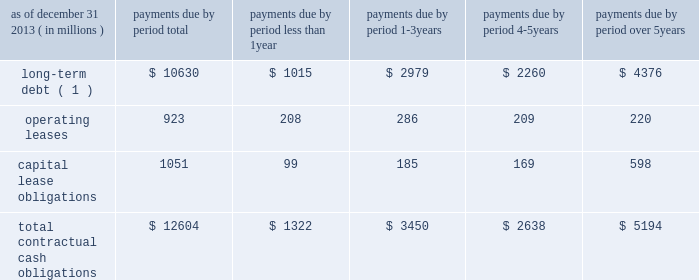Management 2019s discussion and analysis of financial condition and results of operations ( continued ) the npr is generally consistent with the basel committee 2019s lcr .
However , it includes certain more stringent requirements , including an accelerated implementation time line and modifications to the definition of high-quality liquid assets and expected outflow assumptions .
We continue to analyze the proposed rules and analyze their impact as well as develop strategies for compliance .
The principles of the lcr are consistent with our liquidity management framework ; however , the specific calibrations of various elements within the final lcr rule , such as the eligibility of assets as hqla , operational deposit requirements and net outflow requirements could have a material effect on our liquidity , funding and business activities , including the management and composition of our investment securities portfolio and our ability to extend committed contingent credit facilities to our clients .
In january 2014 , the basel committee released a revised proposal with respect to the net stable funding ratio , or nsfr , which will establish a one-year liquidity standard representing the proportion of long-term assets funded by long-term stable funding , scheduled for global implementation in 2018 .
The revised nsfr has made some favorable changes regarding the treatment of operationally linked deposits and a reduction in the funding required for certain securities .
However , we continue to review the specifics of the basel committee's release and will be evaluating the u.s .
Implementation of this standard to analyze the impact and develop strategies for compliance .
U.s .
Banking regulators have not yet issued a proposal to implement the nsfr .
Contractual cash obligations and other commitments the table presents our long-term contractual cash obligations , in total and by period due as of december 31 , 2013 .
These obligations were recorded in our consolidated statement of condition as of that date , except for operating leases and the interest portions of long-term debt and capital leases .
Contractual cash obligations .
( 1 ) long-term debt excludes capital lease obligations ( presented as a separate line item ) and the effect of interest-rate swaps .
Interest payments were calculated at the stated rate with the exception of floating-rate debt , for which payments were calculated using the indexed rate in effect as of december 31 , 2013 .
The table above does not include obligations which will be settled in cash , primarily in less than one year , such as client deposits , federal funds purchased , securities sold under repurchase agreements and other short-term borrowings .
Additional information about deposits , federal funds purchased , securities sold under repurchase agreements and other short-term borrowings is provided in notes 8 and 9 to the consolidated financial statements included under item 8 of this form 10-k .
The table does not include obligations related to derivative instruments because the derivative-related amounts recorded in our consolidated statement of condition as of december 31 , 2013 did not represent the amounts that may ultimately be paid under the contracts upon settlement .
Additional information about our derivative instruments is provided in note 16 to the consolidated financial statements included under item 8 of this form 10-k .
We have obligations under pension and other post-retirement benefit plans , more fully described in note 19 to the consolidated financial statements included under item 8 of this form 10-k , which are not included in the above table .
Additional information about contractual cash obligations related to long-term debt and operating and capital leases is provided in notes 10 and 20 to the consolidated financial statements included under item 8 of this form 10-k .
Our consolidated statement of cash flows , also included under item 8 of this form 10-k , provides additional liquidity information .
The following table presents our commitments , other than the contractual cash obligations presented above , in total and by duration as of december 31 , 2013 .
These commitments were not recorded in our consolidated statement of condition as of that date. .
What portion of the total contractual lease obligations are classified as capital leases? 
Computations: (1051 / (923 + 1051))
Answer: 0.53242. 